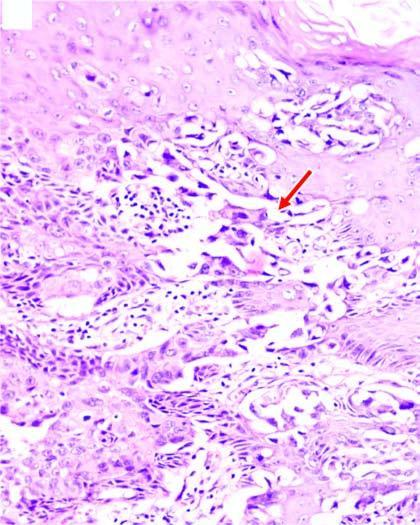re there clefts in the epidermal layers containing large tumour cells?
Answer the question using a single word or phrase. Yes 